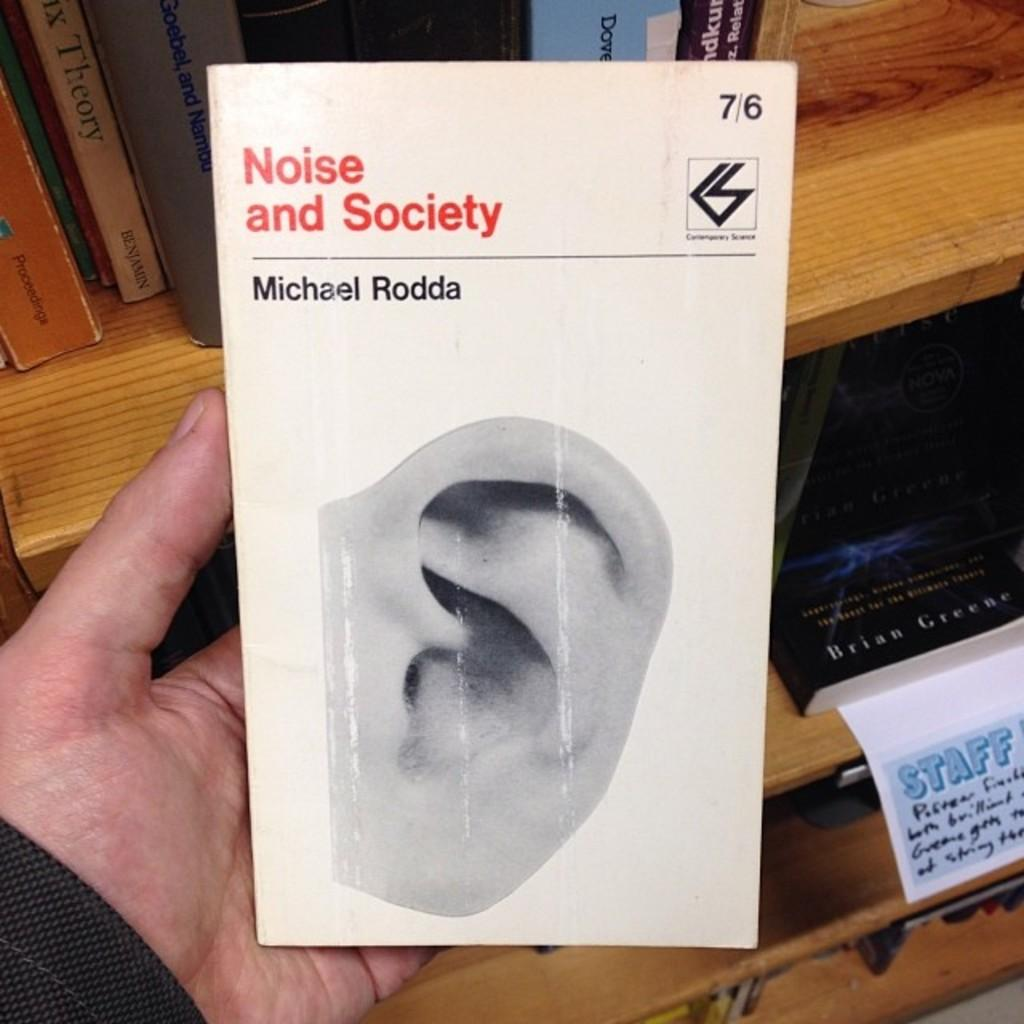<image>
Present a compact description of the photo's key features. A hand is holding a booked titled Noise and Society by Michael Rodda 